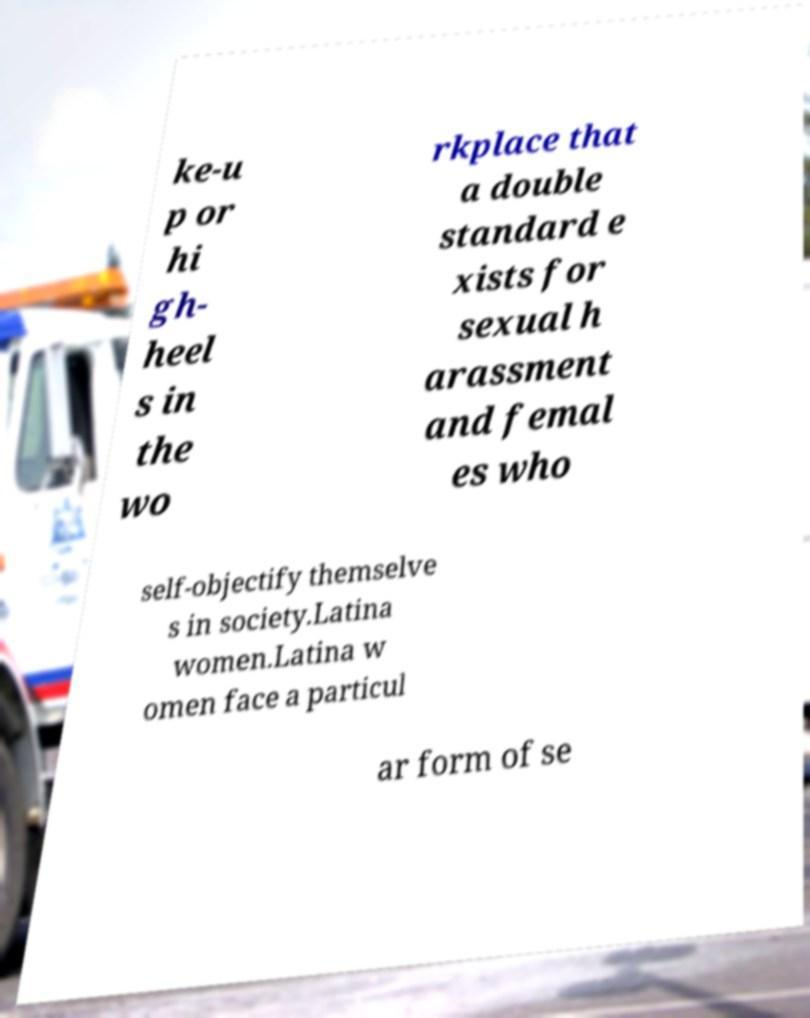What messages or text are displayed in this image? I need them in a readable, typed format. ke-u p or hi gh- heel s in the wo rkplace that a double standard e xists for sexual h arassment and femal es who self-objectify themselve s in society.Latina women.Latina w omen face a particul ar form of se 